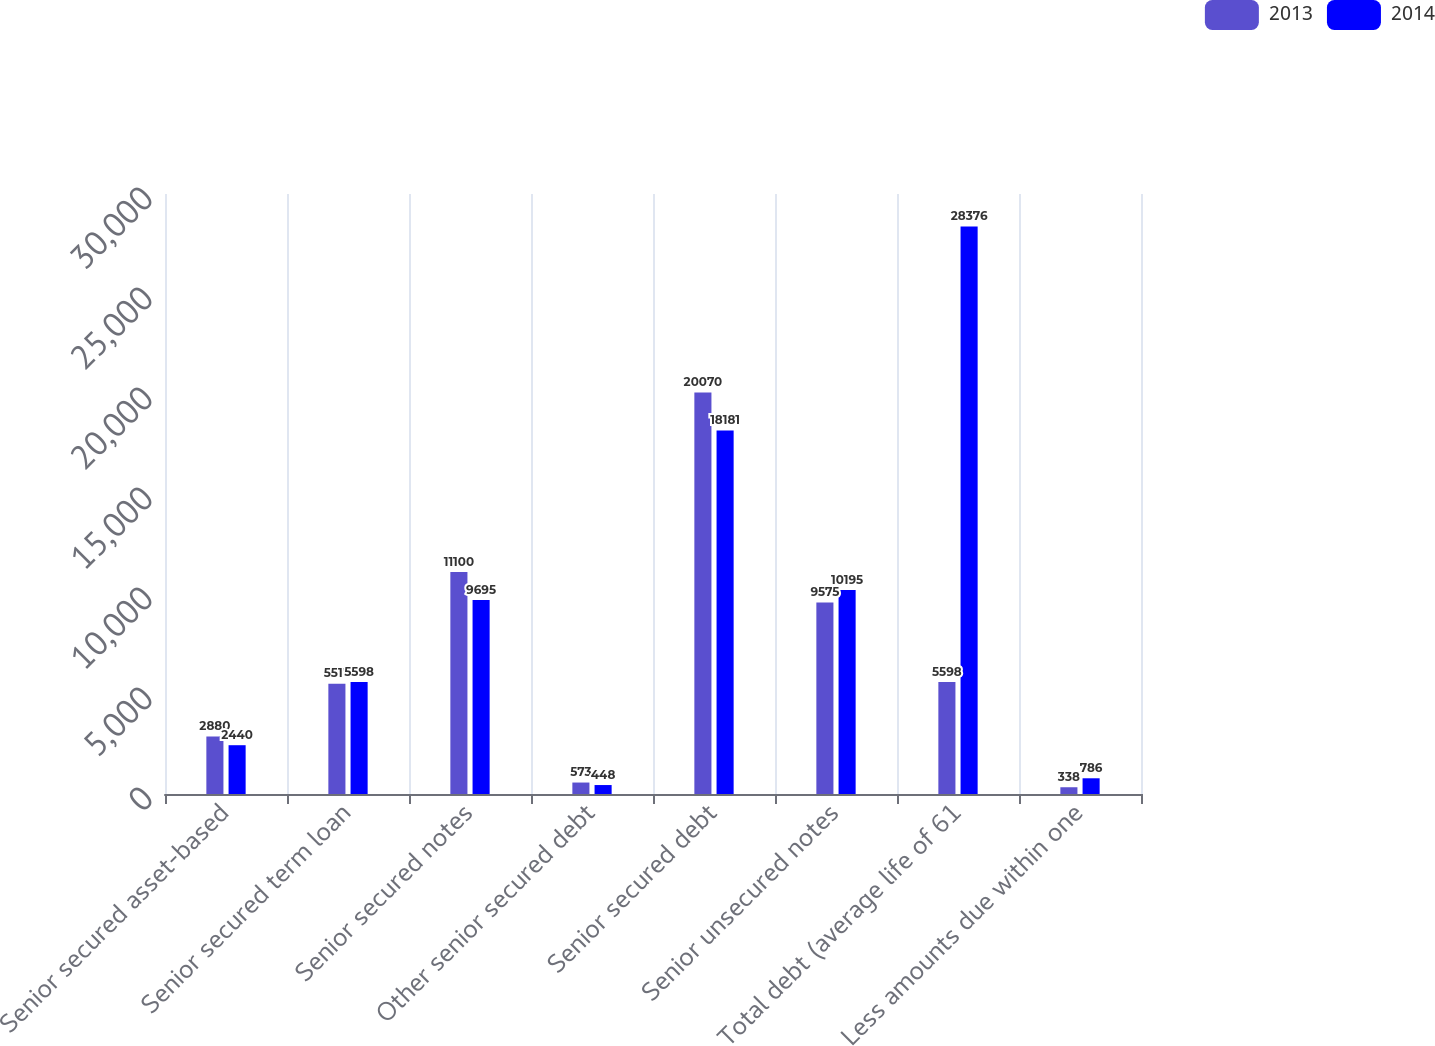Convert chart to OTSL. <chart><loc_0><loc_0><loc_500><loc_500><stacked_bar_chart><ecel><fcel>Senior secured asset-based<fcel>Senior secured term loan<fcel>Senior secured notes<fcel>Other senior secured debt<fcel>Senior secured debt<fcel>Senior unsecured notes<fcel>Total debt (average life of 61<fcel>Less amounts due within one<nl><fcel>2013<fcel>2880<fcel>5517<fcel>11100<fcel>573<fcel>20070<fcel>9575<fcel>5598<fcel>338<nl><fcel>2014<fcel>2440<fcel>5598<fcel>9695<fcel>448<fcel>18181<fcel>10195<fcel>28376<fcel>786<nl></chart> 